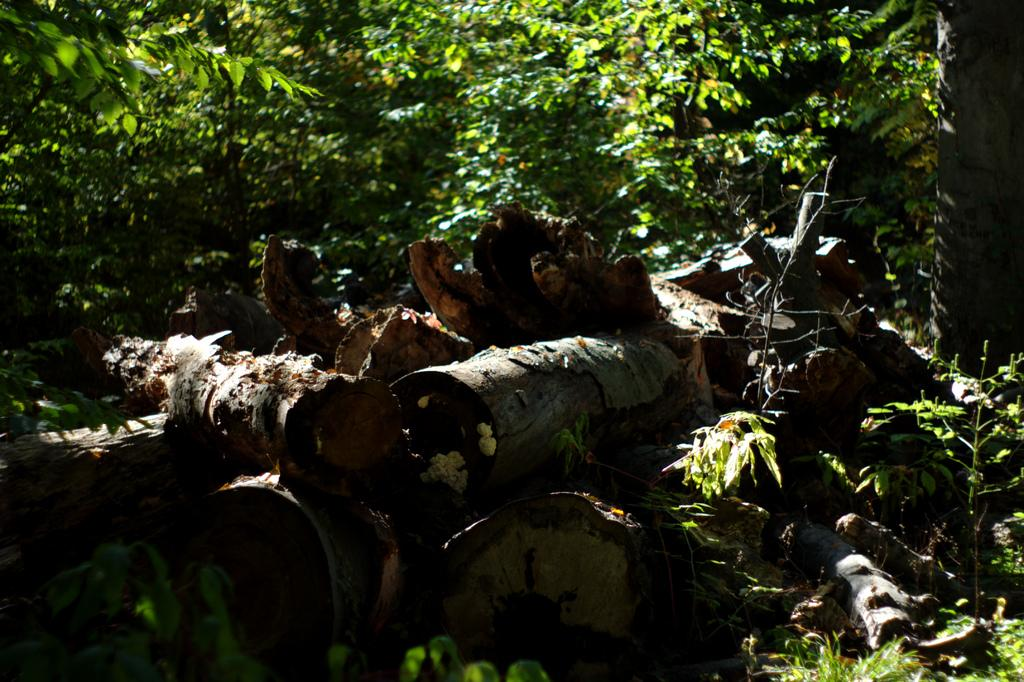What objects can be seen in the image? There are logs and plants in the image. Can you describe the natural elements in the image? There are trees in the background of the image. What type of science experiment is being conducted in the image? There is no science experiment present in the image; it features logs, plants, and trees. How does the rainstorm affect the scene in the image? There is no rainstorm present in the image, so its effect cannot be determined. 